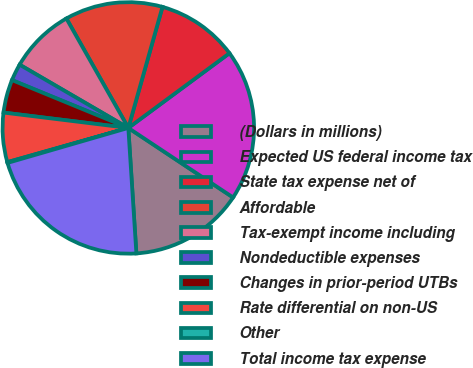<chart> <loc_0><loc_0><loc_500><loc_500><pie_chart><fcel>(Dollars in millions)<fcel>Expected US federal income tax<fcel>State tax expense net of<fcel>Affordable<fcel>Tax-exempt income including<fcel>Nondeductible expenses<fcel>Changes in prior-period UTBs<fcel>Rate differential on non-US<fcel>Other<fcel>Total income tax expense<nl><fcel>14.66%<fcel>19.46%<fcel>10.5%<fcel>12.58%<fcel>8.42%<fcel>2.18%<fcel>4.26%<fcel>6.34%<fcel>0.1%<fcel>21.54%<nl></chart> 